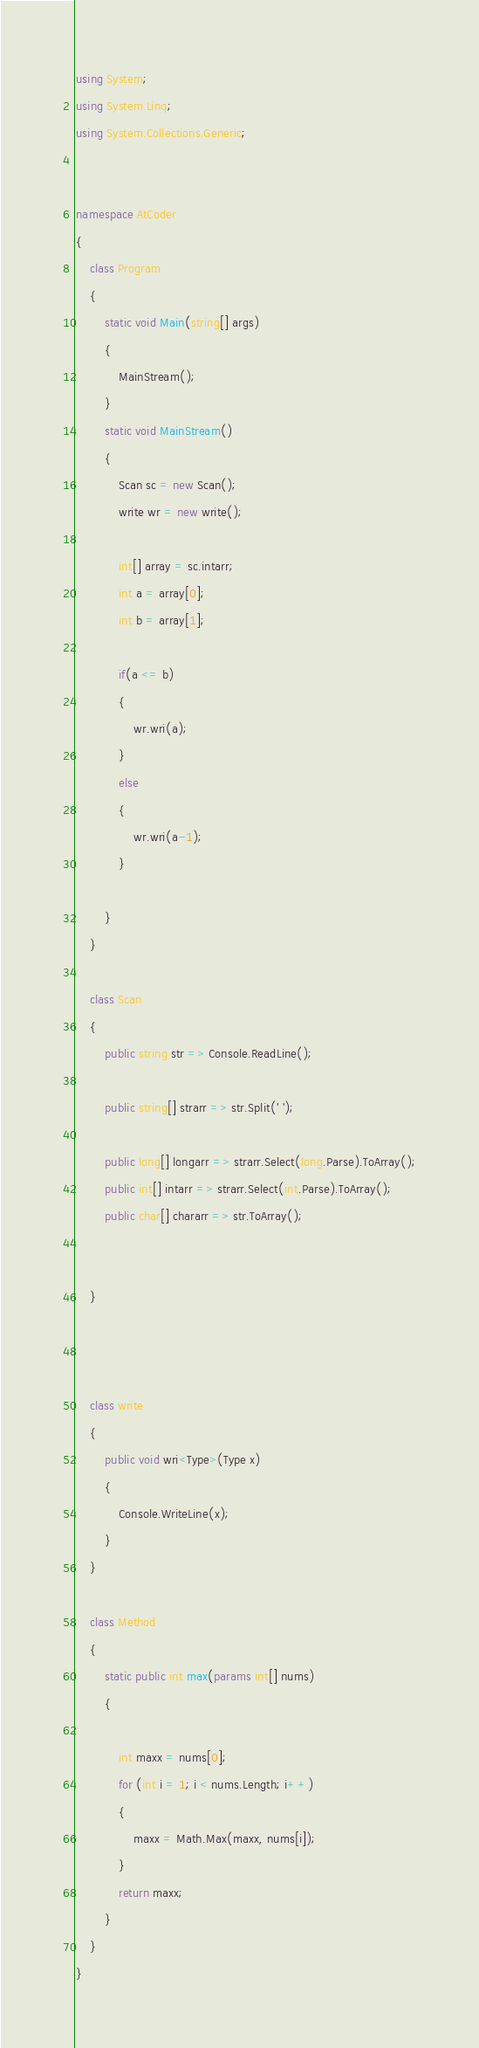<code> <loc_0><loc_0><loc_500><loc_500><_C#_>using System;
using System.Linq;
using System.Collections.Generic;


namespace AtCoder
{
    class Program
    {
        static void Main(string[] args)
        {
            MainStream();
        }
        static void MainStream()
        {
            Scan sc = new Scan();
            write wr = new write();

            int[] array = sc.intarr;
            int a = array[0];
            int b = array[1];

            if(a <= b)
            {
                wr.wri(a);
            }
            else
            {
                wr.wri(a-1);
            }

        }
    }

    class Scan
    {
        public string str => Console.ReadLine();

        public string[] strarr => str.Split(' ');

        public long[] longarr => strarr.Select(long.Parse).ToArray();
        public int[] intarr => strarr.Select(int.Parse).ToArray();
        public char[] chararr => str.ToArray();


    }



    class write
    {
        public void wri<Type>(Type x)
        {
            Console.WriteLine(x);
        }
    }

    class Method
    {
        static public int max(params int[] nums)
        {

            int maxx = nums[0];
            for (int i = 1; i < nums.Length; i++)
            {
                maxx = Math.Max(maxx, nums[i]);
            }
            return maxx;
        }
    }
}
</code> 